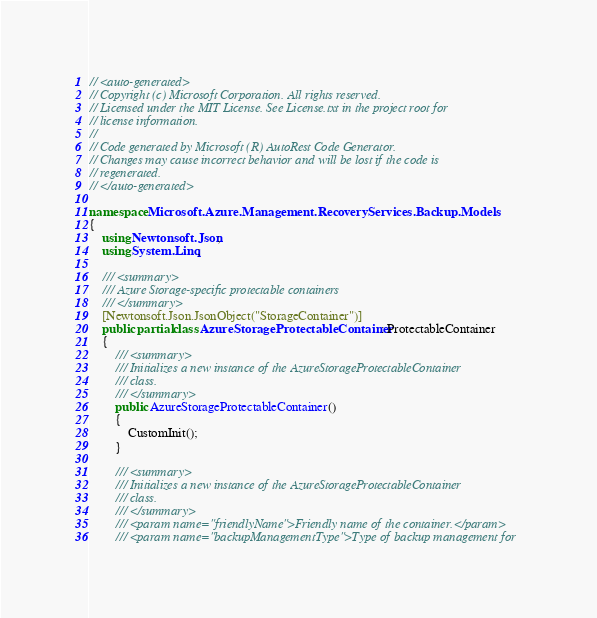<code> <loc_0><loc_0><loc_500><loc_500><_C#_>// <auto-generated>
// Copyright (c) Microsoft Corporation. All rights reserved.
// Licensed under the MIT License. See License.txt in the project root for
// license information.
//
// Code generated by Microsoft (R) AutoRest Code Generator.
// Changes may cause incorrect behavior and will be lost if the code is
// regenerated.
// </auto-generated>

namespace Microsoft.Azure.Management.RecoveryServices.Backup.Models
{
    using Newtonsoft.Json;
    using System.Linq;

    /// <summary>
    /// Azure Storage-specific protectable containers
    /// </summary>
    [Newtonsoft.Json.JsonObject("StorageContainer")]
    public partial class AzureStorageProtectableContainer : ProtectableContainer
    {
        /// <summary>
        /// Initializes a new instance of the AzureStorageProtectableContainer
        /// class.
        /// </summary>
        public AzureStorageProtectableContainer()
        {
            CustomInit();
        }

        /// <summary>
        /// Initializes a new instance of the AzureStorageProtectableContainer
        /// class.
        /// </summary>
        /// <param name="friendlyName">Friendly name of the container.</param>
        /// <param name="backupManagementType">Type of backup management for</code> 